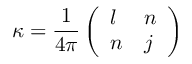<formula> <loc_0><loc_0><loc_500><loc_500>\kappa = { \frac { 1 } { 4 \pi } } \left ( \begin{array} { l l } { l } & { n } \\ { n } & { j } \end{array} \right )</formula> 